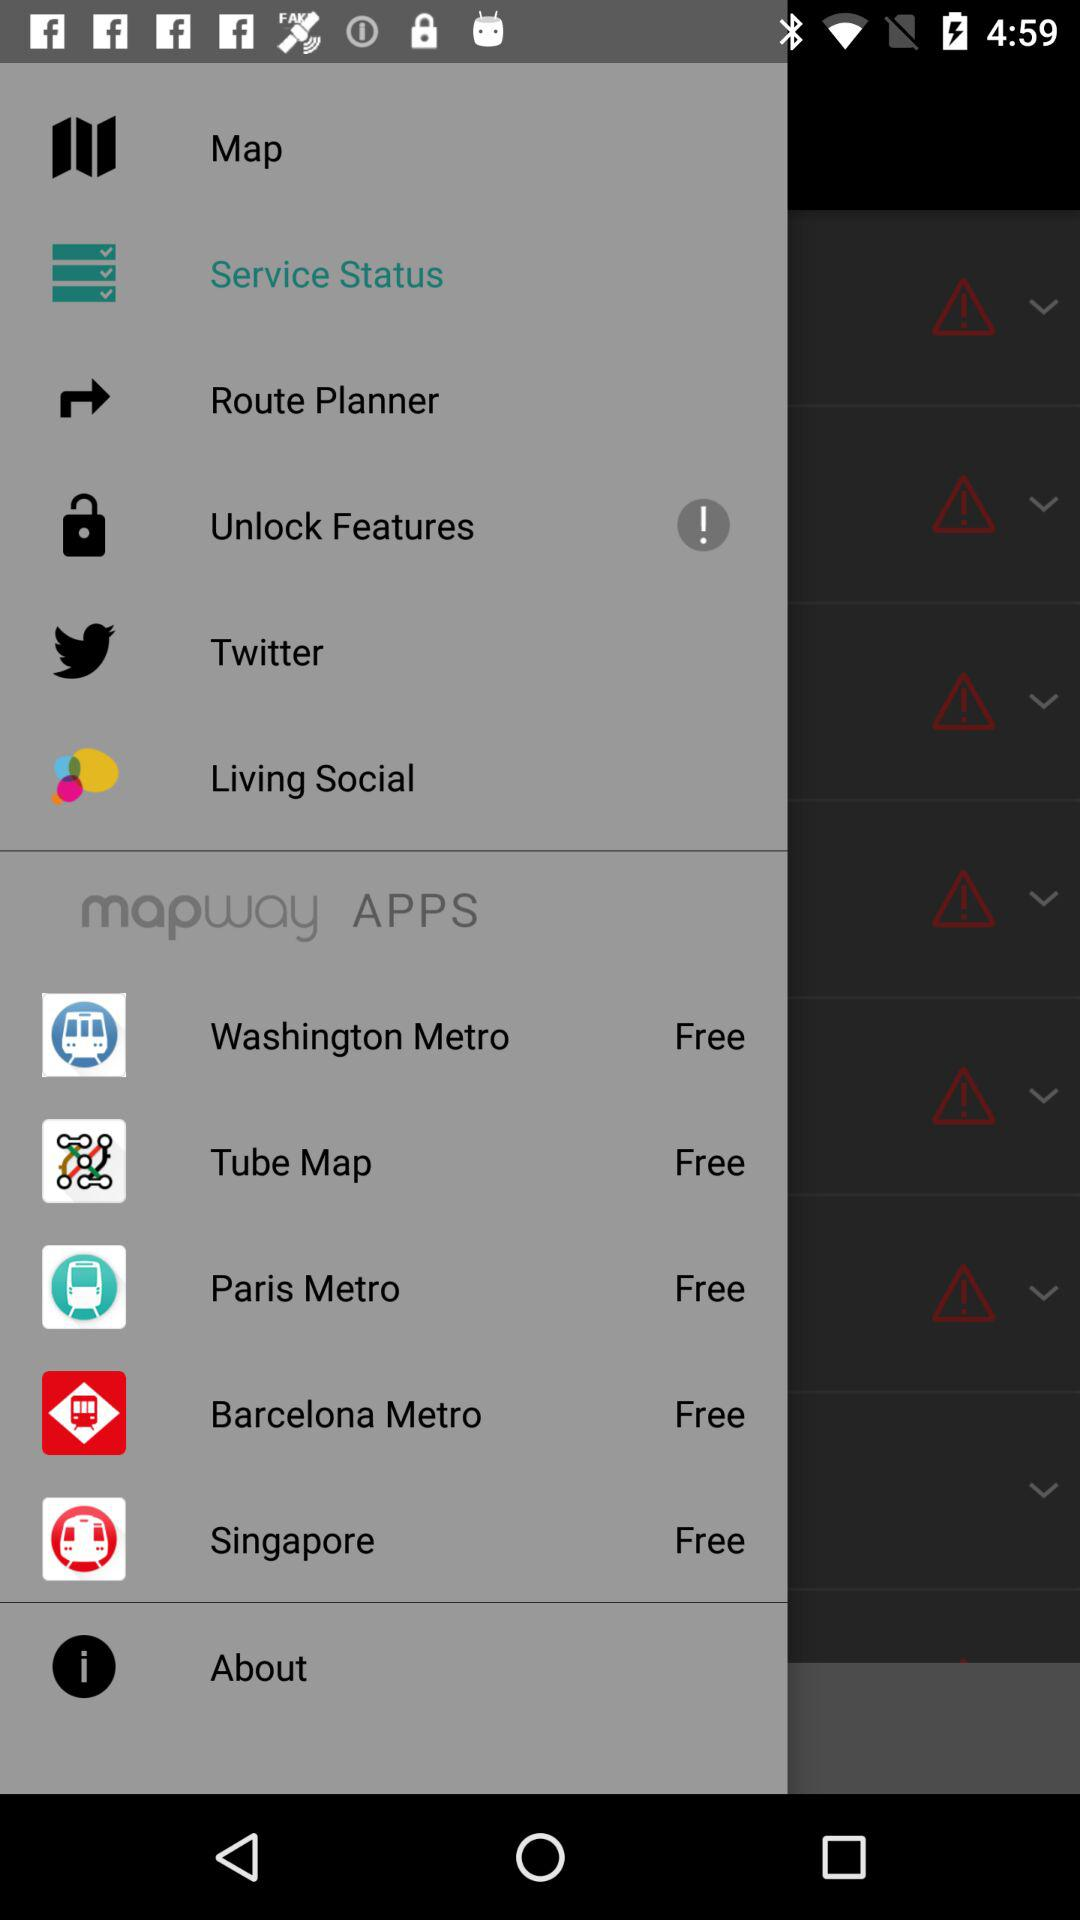What are the names of some free mapway applications? The names are "Washington Metro", "Tube Map", "Paris Metro", "Barcelona Metro" and "Singapore". 